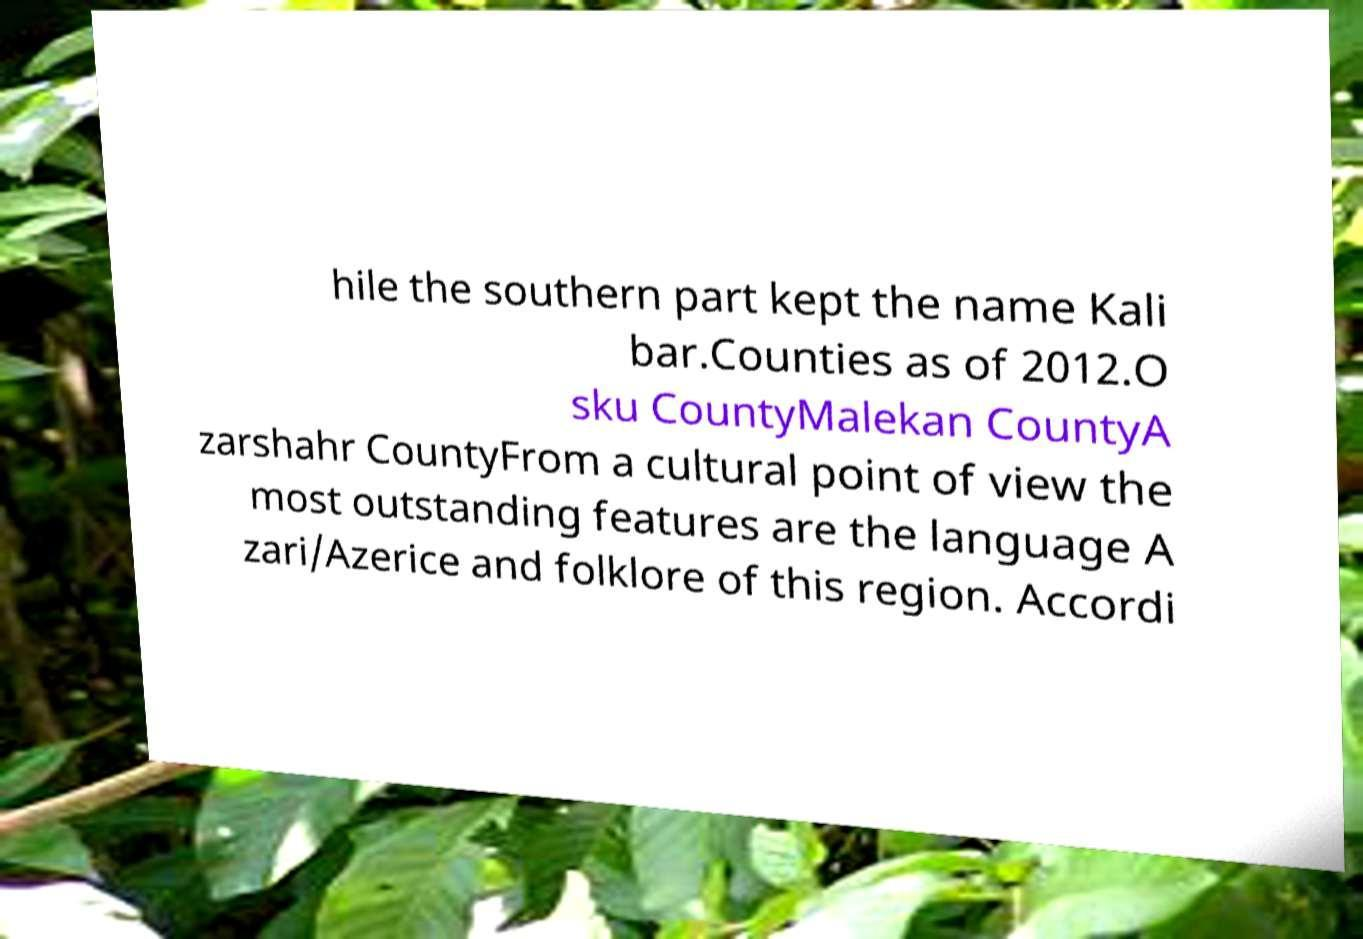Can you read and provide the text displayed in the image?This photo seems to have some interesting text. Can you extract and type it out for me? hile the southern part kept the name Kali bar.Counties as of 2012.O sku CountyMalekan CountyA zarshahr CountyFrom a cultural point of view the most outstanding features are the language A zari/Azerice and folklore of this region. Accordi 